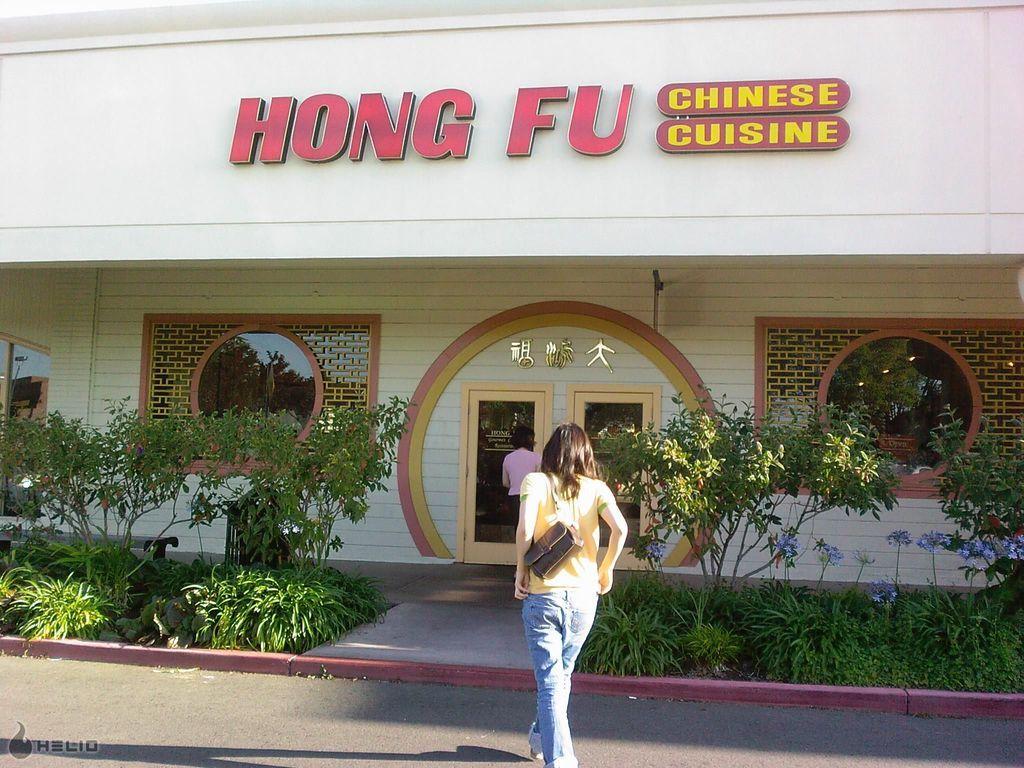Could you give a brief overview of what you see in this image? In the center of the image a lady is walking and carrying bag. In the background of the image we can see building, doors, windows, wall, boards, plants, flowers. At the bottom of the image there is a road. 